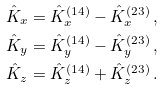Convert formula to latex. <formula><loc_0><loc_0><loc_500><loc_500>\hat { K } _ { x } & = \hat { K } _ { x } ^ { ( 1 4 ) } - \hat { K } _ { x } ^ { ( 2 3 ) } \, , \\ \hat { K } _ { y } & = \hat { K } _ { y } ^ { ( 1 4 ) } - \hat { K } _ { y } ^ { ( 2 3 ) } \, , \\ \hat { K } _ { z } & = \hat { K } _ { z } ^ { ( 1 4 ) } + \hat { K } _ { z } ^ { ( 2 3 ) } \, .</formula> 